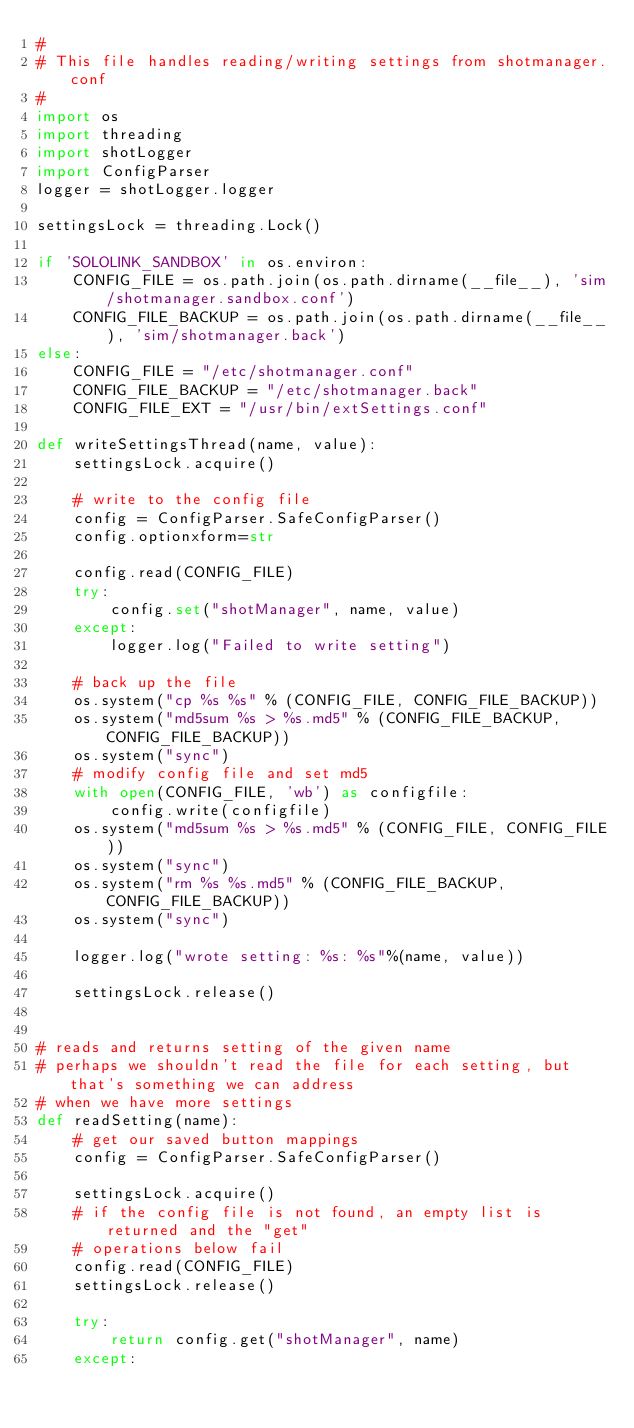Convert code to text. <code><loc_0><loc_0><loc_500><loc_500><_Python_>#
# This file handles reading/writing settings from shotmanager.conf
#
import os
import threading
import shotLogger
import ConfigParser
logger = shotLogger.logger

settingsLock = threading.Lock()

if 'SOLOLINK_SANDBOX' in os.environ:
    CONFIG_FILE = os.path.join(os.path.dirname(__file__), 'sim/shotmanager.sandbox.conf')
    CONFIG_FILE_BACKUP = os.path.join(os.path.dirname(__file__), 'sim/shotmanager.back')
else:
    CONFIG_FILE = "/etc/shotmanager.conf"
    CONFIG_FILE_BACKUP = "/etc/shotmanager.back"
    CONFIG_FILE_EXT = "/usr/bin/extSettings.conf"

def writeSettingsThread(name, value):
    settingsLock.acquire()

    # write to the config file
    config = ConfigParser.SafeConfigParser()
    config.optionxform=str

    config.read(CONFIG_FILE)
    try:
        config.set("shotManager", name, value)
    except:
        logger.log("Failed to write setting")

    # back up the file
    os.system("cp %s %s" % (CONFIG_FILE, CONFIG_FILE_BACKUP))
    os.system("md5sum %s > %s.md5" % (CONFIG_FILE_BACKUP, CONFIG_FILE_BACKUP))
    os.system("sync")
    # modify config file and set md5
    with open(CONFIG_FILE, 'wb') as configfile:
        config.write(configfile)
    os.system("md5sum %s > %s.md5" % (CONFIG_FILE, CONFIG_FILE))
    os.system("sync")
    os.system("rm %s %s.md5" % (CONFIG_FILE_BACKUP, CONFIG_FILE_BACKUP))
    os.system("sync")

    logger.log("wrote setting: %s: %s"%(name, value))

    settingsLock.release()


# reads and returns setting of the given name
# perhaps we shouldn't read the file for each setting, but that's something we can address
# when we have more settings
def readSetting(name):
    # get our saved button mappings
    config = ConfigParser.SafeConfigParser()

    settingsLock.acquire()
    # if the config file is not found, an empty list is returned and the "get"
    # operations below fail
    config.read(CONFIG_FILE)
    settingsLock.release()

    try:
        return config.get("shotManager", name)
    except:</code> 